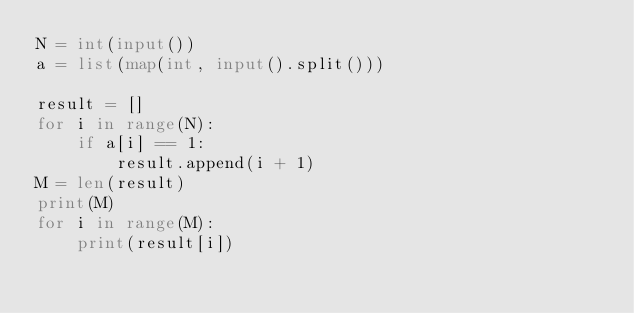Convert code to text. <code><loc_0><loc_0><loc_500><loc_500><_Python_>N = int(input())
a = list(map(int, input().split()))

result = []
for i in range(N):
    if a[i] == 1:
        result.append(i + 1)
M = len(result)
print(M)
for i in range(M):
    print(result[i])</code> 